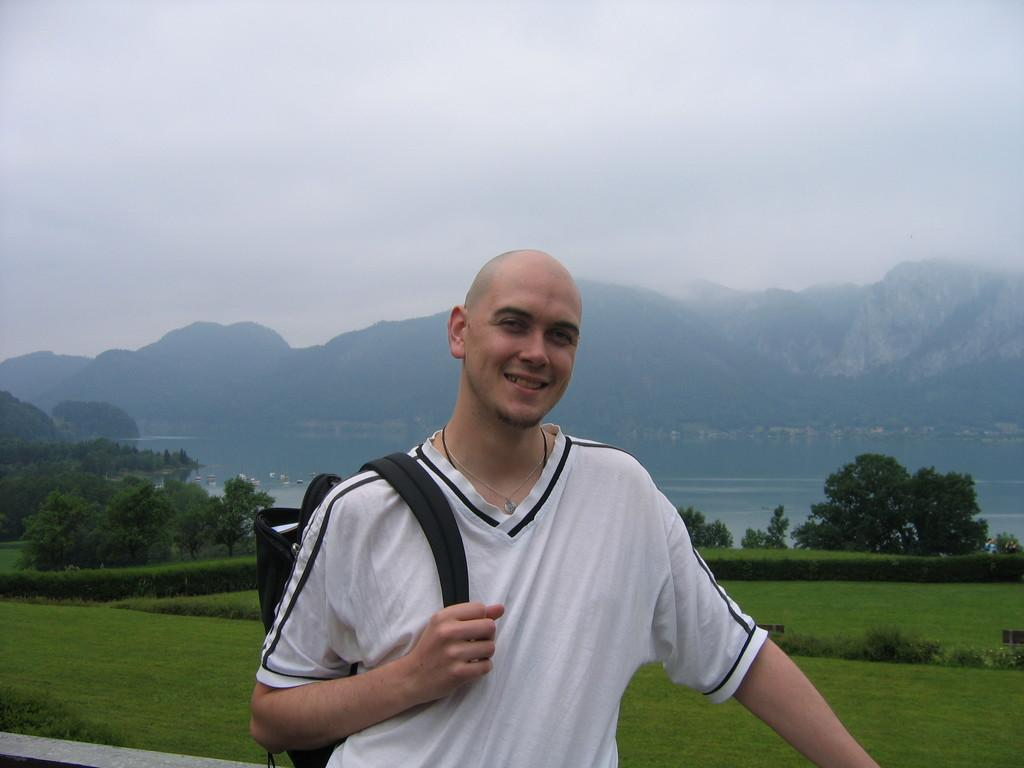What is the main subject of the image? There is a person in the image. What is the person holding in the image? The person is holding a bag. What type of natural environment is visible in the image? There is grass, trees, and hills visible in the image. What type of pencil can be seen in the person's hand in the image? There is no pencil visible in the person's hand in the image. How many knots are tied in the bag the person is holding? There is no information about knots in the bag the person is holding, as the focus is on the person holding the bag. 